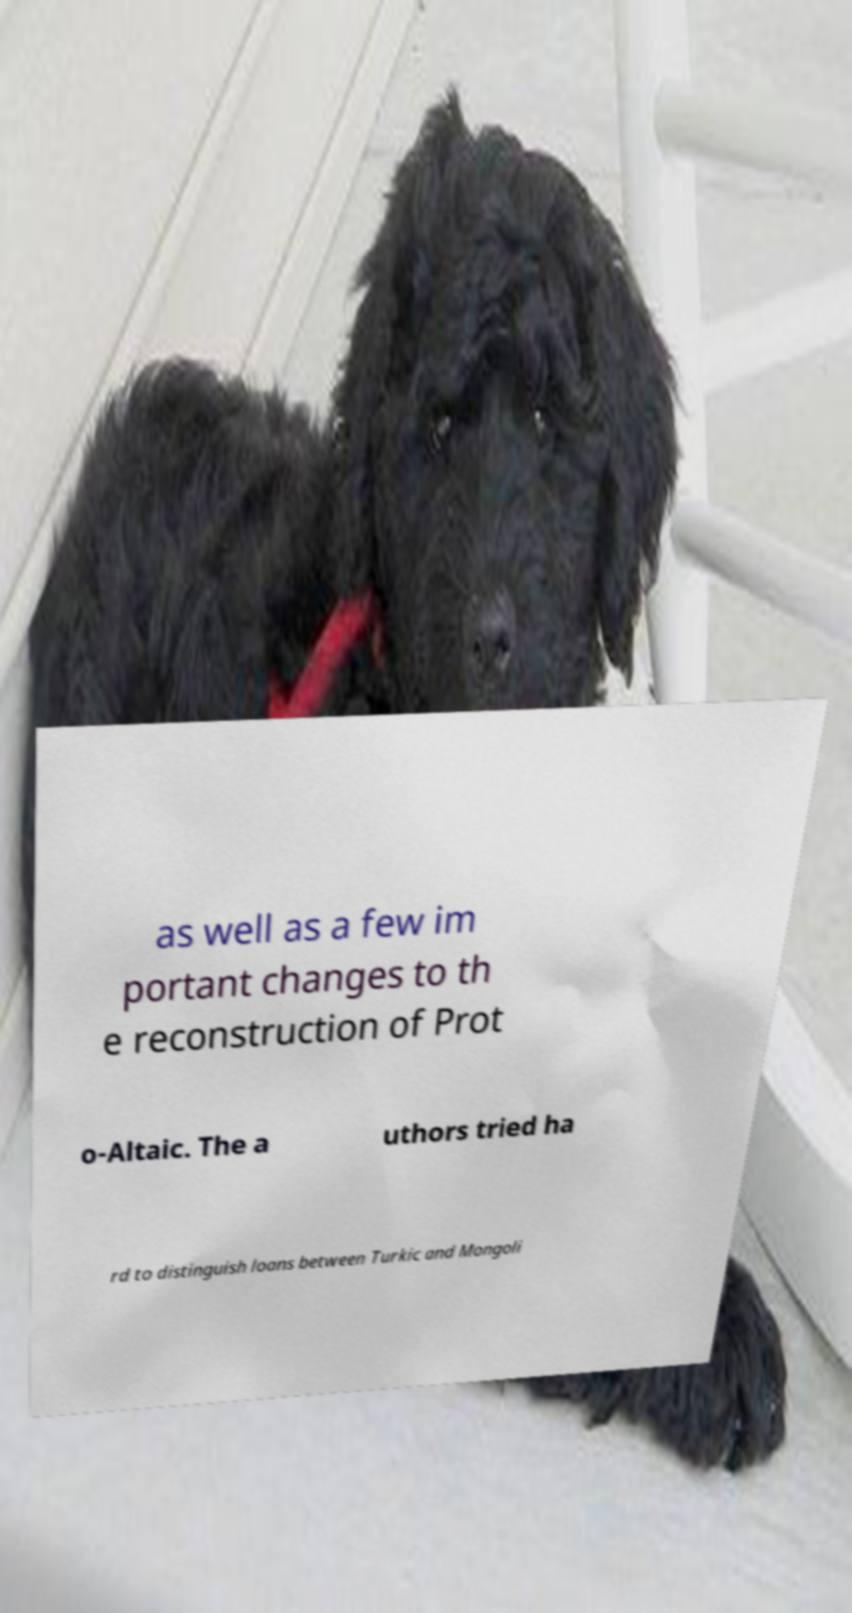Please identify and transcribe the text found in this image. as well as a few im portant changes to th e reconstruction of Prot o-Altaic. The a uthors tried ha rd to distinguish loans between Turkic and Mongoli 